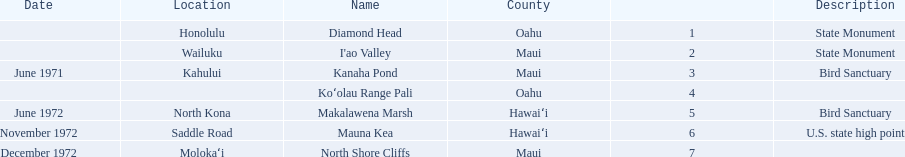What are all of the national natural landmarks in hawaii? Diamond Head, I'ao Valley, Kanaha Pond, Koʻolau Range Pali, Makalawena Marsh, Mauna Kea, North Shore Cliffs. Which ones of those national natural landmarks in hawaii are in the county of hawai'i? Makalawena Marsh, Mauna Kea. Which is the only national natural landmark in hawaii that is also a u.s. state high point? Mauna Kea. 